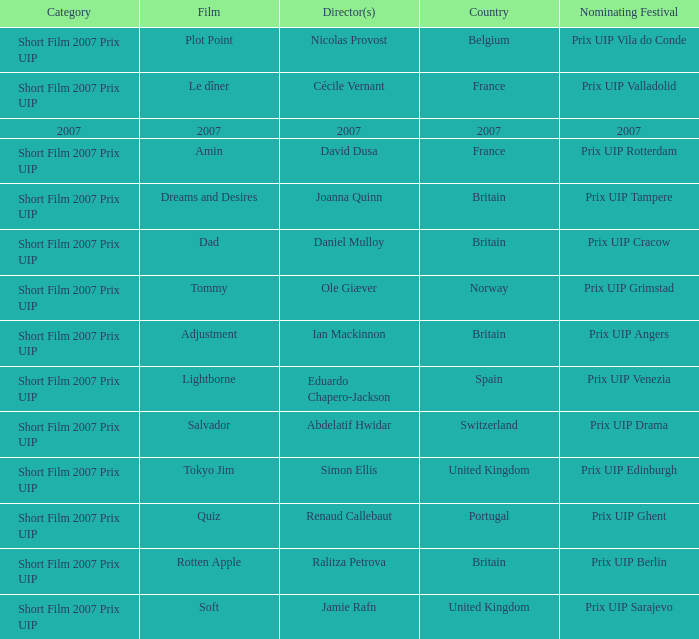Could you parse the entire table as a dict? {'header': ['Category', 'Film', 'Director(s)', 'Country', 'Nominating Festival'], 'rows': [['Short Film 2007 Prix UIP', 'Plot Point', 'Nicolas Provost', 'Belgium', 'Prix UIP Vila do Conde'], ['Short Film 2007 Prix UIP', 'Le dîner', 'Cécile Vernant', 'France', 'Prix UIP Valladolid'], ['2007', '2007', '2007', '2007', '2007'], ['Short Film 2007 Prix UIP', 'Amin', 'David Dusa', 'France', 'Prix UIP Rotterdam'], ['Short Film 2007 Prix UIP', 'Dreams and Desires', 'Joanna Quinn', 'Britain', 'Prix UIP Tampere'], ['Short Film 2007 Prix UIP', 'Dad', 'Daniel Mulloy', 'Britain', 'Prix UIP Cracow'], ['Short Film 2007 Prix UIP', 'Tommy', 'Ole Giæver', 'Norway', 'Prix UIP Grimstad'], ['Short Film 2007 Prix UIP', 'Adjustment', 'Ian Mackinnon', 'Britain', 'Prix UIP Angers'], ['Short Film 2007 Prix UIP', 'Lightborne', 'Eduardo Chapero-Jackson', 'Spain', 'Prix UIP Venezia'], ['Short Film 2007 Prix UIP', 'Salvador', 'Abdelatif Hwidar', 'Switzerland', 'Prix UIP Drama'], ['Short Film 2007 Prix UIP', 'Tokyo Jim', 'Simon Ellis', 'United Kingdom', 'Prix UIP Edinburgh'], ['Short Film 2007 Prix UIP', 'Quiz', 'Renaud Callebaut', 'Portugal', 'Prix UIP Ghent'], ['Short Film 2007 Prix UIP', 'Rotten Apple', 'Ralitza Petrova', 'Britain', 'Prix UIP Berlin'], ['Short Film 2007 Prix UIP', 'Soft', 'Jamie Rafn', 'United Kingdom', 'Prix UIP Sarajevo']]} What Country has a Director of 2007? 2007.0. 